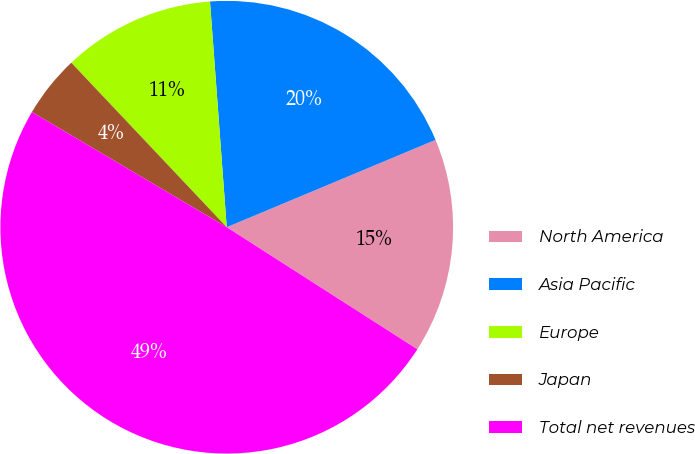<chart> <loc_0><loc_0><loc_500><loc_500><pie_chart><fcel>North America<fcel>Asia Pacific<fcel>Europe<fcel>Japan<fcel>Total net revenues<nl><fcel>15.37%<fcel>19.87%<fcel>10.87%<fcel>4.45%<fcel>49.43%<nl></chart> 